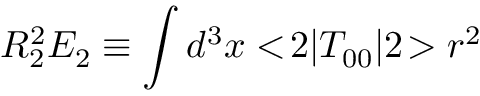<formula> <loc_0><loc_0><loc_500><loc_500>R _ { 2 } ^ { 2 } E _ { 2 } \equiv \int d ^ { 3 } x < \, 2 | T _ { 0 0 } | 2 \, > r ^ { 2 }</formula> 